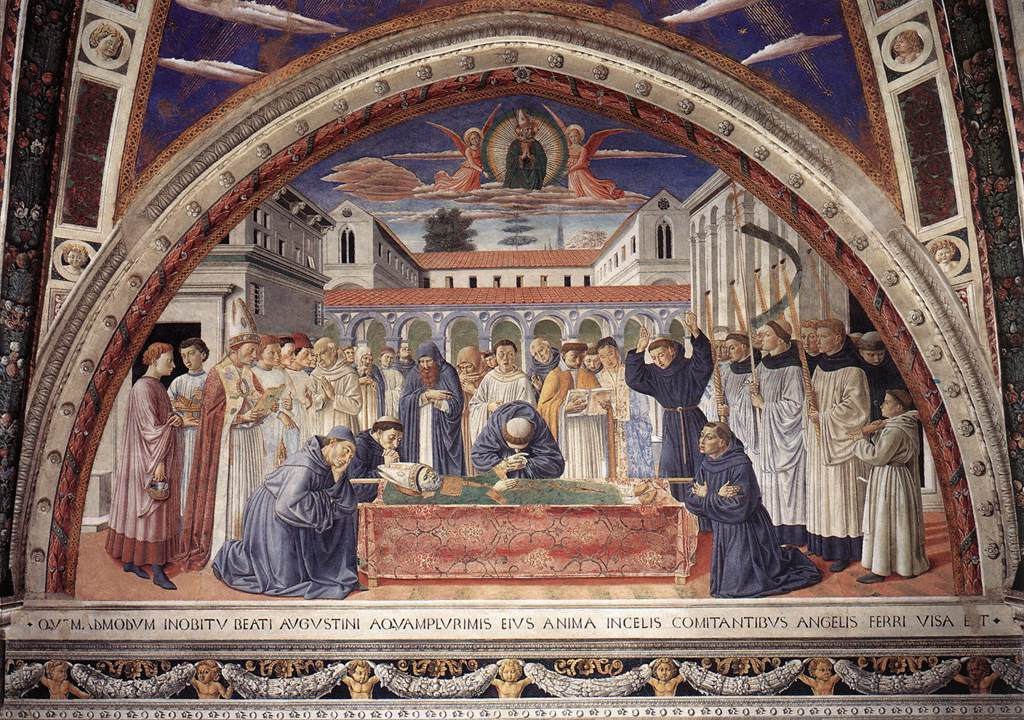Let's imagine this scene is part of a larger story. What events might be happening before and after this moment? Imagine a grand tale spanning years, where the central figure is a revered leader or saint who has just performed a series of miraculous acts, benefiting the community. Before this moment, people from neighboring regions have gathered to witness his final teachings and blessings. The courtyard is filled with the echoes of his last words, prayers, and the soft murmur of a devoted crowd.

After this solemn scene, the story might unfold with the community continuing his legacy, inspired by his teachings. They might establish a sanctuary in his honor, further enshrining his memory through art, tradition, and continued acts of goodwill, forever cherishing the wisdom and peace he imparted. How do the colors used in the painting enhance its overall impact? The use of rich colors like red, blue, and gold in the painting profoundly enhances its impact. Red conveys passion and intensity, bringing the figures to life. Blue imparts a sense of calm and solemnity, appropriate for the depicted event. Gold adds a divine and royal touch, highlighting the significance of the scene. These colors, combined with the intricate details and shading, create a vivid, emotional, and immersive experience for the viewer. If the fresco were a portal to another world, what kind of adventure would you have upon entering? Stepping into this fresco might transport you to a world where history and fantasy intertwine. You find yourself in a grand medieval city, where the spirit of the central figure continues to guide and protect the inhabitants. Embarking on an adventure, you uncover hidden truths about the figure's past, encounter mystical creatures, and navigate ancient challenges to preserve the harmony he once fostered. Your quest is to keep the legacy alive, ensuring the city's wisdom and peace endure against emerging threats, all within a realm of magic, valor, and enduring faith. 